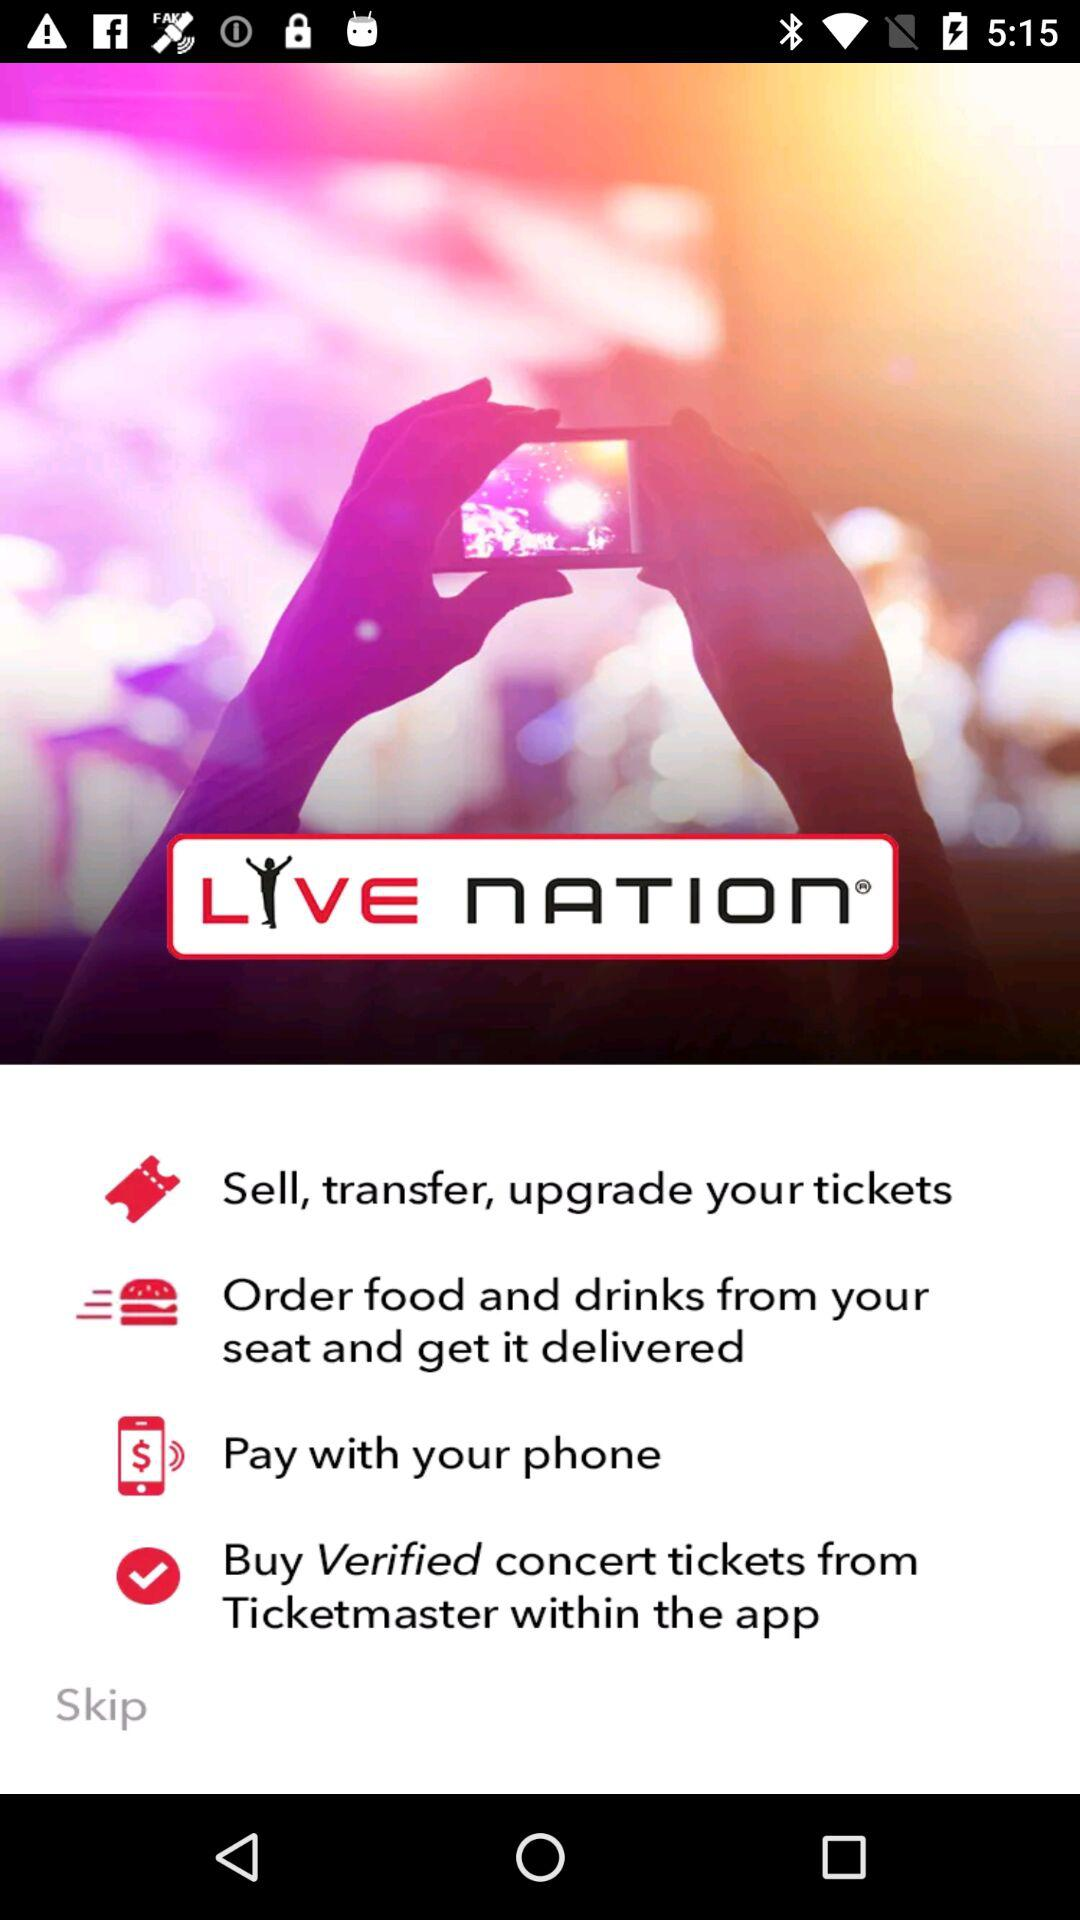What can we do in the Live Nation application? We can "Sell, transfer, upgrade your tickets", "Order food and drinks from your seat and get it delivered", "Pay with your phone" and "Buy Verified concert tickets from Ticketmaster within the app". 